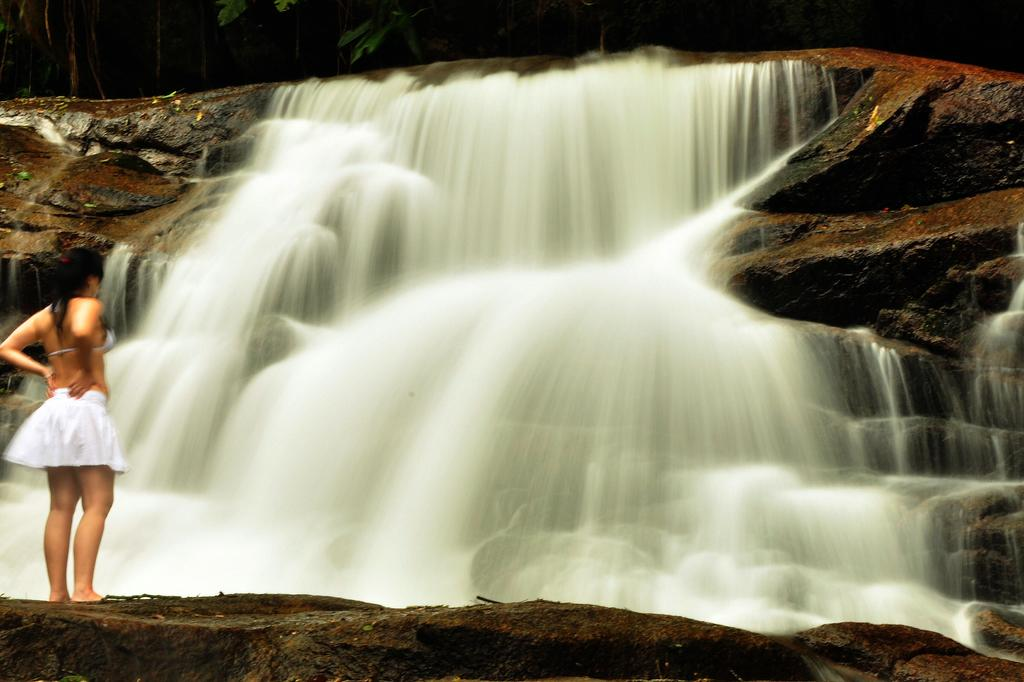What is the main subject of the image? There is a girl standing in the image. Can you describe what the girl is wearing? The girl is wearing clothes. What natural feature can be seen in the background of the image? There is a waterfall in the image. What type of objects are present on the ground in the image? Stones are present in the image. What type of vegetation can be seen in the image? Leaves are visible in the image. What type of lumber is being used to construct the town in the image? There is no town present in the image, so there is no lumber being used for construction. Can you tell me how many elbows the girl has in the image? The number of elbows a person has is not dependent on the image; it is a consistent biological feature. 